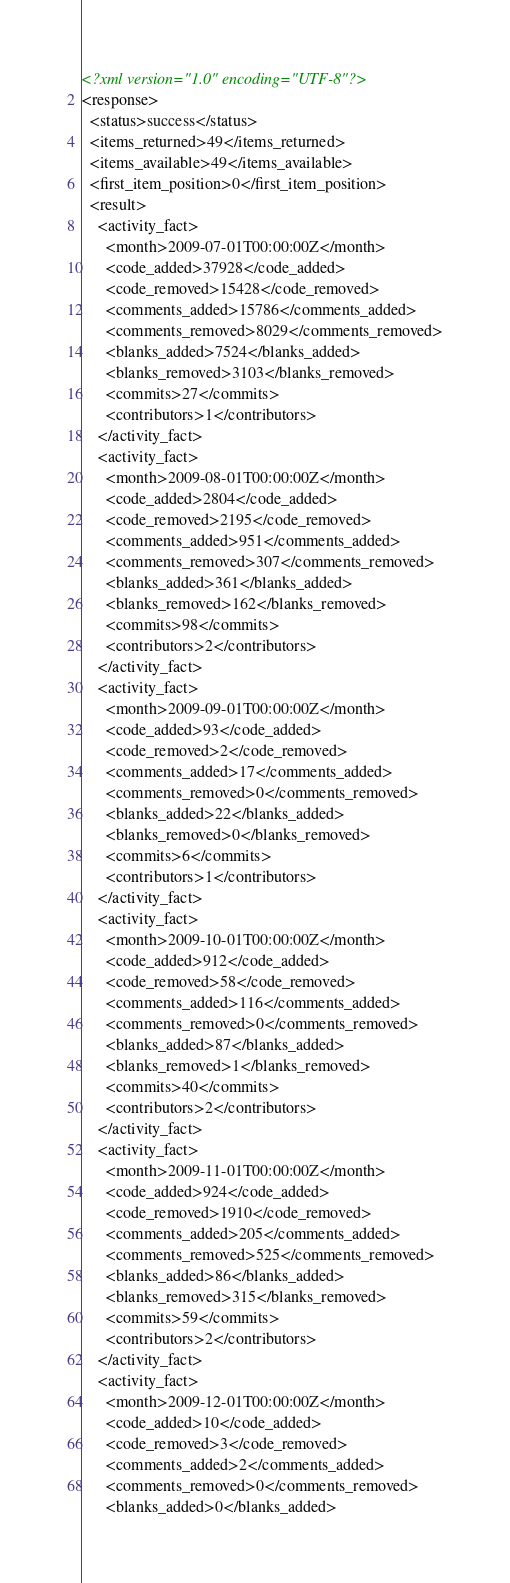<code> <loc_0><loc_0><loc_500><loc_500><_XML_><?xml version="1.0" encoding="UTF-8"?>
<response>
  <status>success</status>
  <items_returned>49</items_returned>
  <items_available>49</items_available>
  <first_item_position>0</first_item_position>
  <result>
    <activity_fact>
      <month>2009-07-01T00:00:00Z</month>
      <code_added>37928</code_added>
      <code_removed>15428</code_removed>
      <comments_added>15786</comments_added>
      <comments_removed>8029</comments_removed>
      <blanks_added>7524</blanks_added>
      <blanks_removed>3103</blanks_removed>
      <commits>27</commits>
      <contributors>1</contributors>
    </activity_fact>
    <activity_fact>
      <month>2009-08-01T00:00:00Z</month>
      <code_added>2804</code_added>
      <code_removed>2195</code_removed>
      <comments_added>951</comments_added>
      <comments_removed>307</comments_removed>
      <blanks_added>361</blanks_added>
      <blanks_removed>162</blanks_removed>
      <commits>98</commits>
      <contributors>2</contributors>
    </activity_fact>
    <activity_fact>
      <month>2009-09-01T00:00:00Z</month>
      <code_added>93</code_added>
      <code_removed>2</code_removed>
      <comments_added>17</comments_added>
      <comments_removed>0</comments_removed>
      <blanks_added>22</blanks_added>
      <blanks_removed>0</blanks_removed>
      <commits>6</commits>
      <contributors>1</contributors>
    </activity_fact>
    <activity_fact>
      <month>2009-10-01T00:00:00Z</month>
      <code_added>912</code_added>
      <code_removed>58</code_removed>
      <comments_added>116</comments_added>
      <comments_removed>0</comments_removed>
      <blanks_added>87</blanks_added>
      <blanks_removed>1</blanks_removed>
      <commits>40</commits>
      <contributors>2</contributors>
    </activity_fact>
    <activity_fact>
      <month>2009-11-01T00:00:00Z</month>
      <code_added>924</code_added>
      <code_removed>1910</code_removed>
      <comments_added>205</comments_added>
      <comments_removed>525</comments_removed>
      <blanks_added>86</blanks_added>
      <blanks_removed>315</blanks_removed>
      <commits>59</commits>
      <contributors>2</contributors>
    </activity_fact>
    <activity_fact>
      <month>2009-12-01T00:00:00Z</month>
      <code_added>10</code_added>
      <code_removed>3</code_removed>
      <comments_added>2</comments_added>
      <comments_removed>0</comments_removed>
      <blanks_added>0</blanks_added></code> 